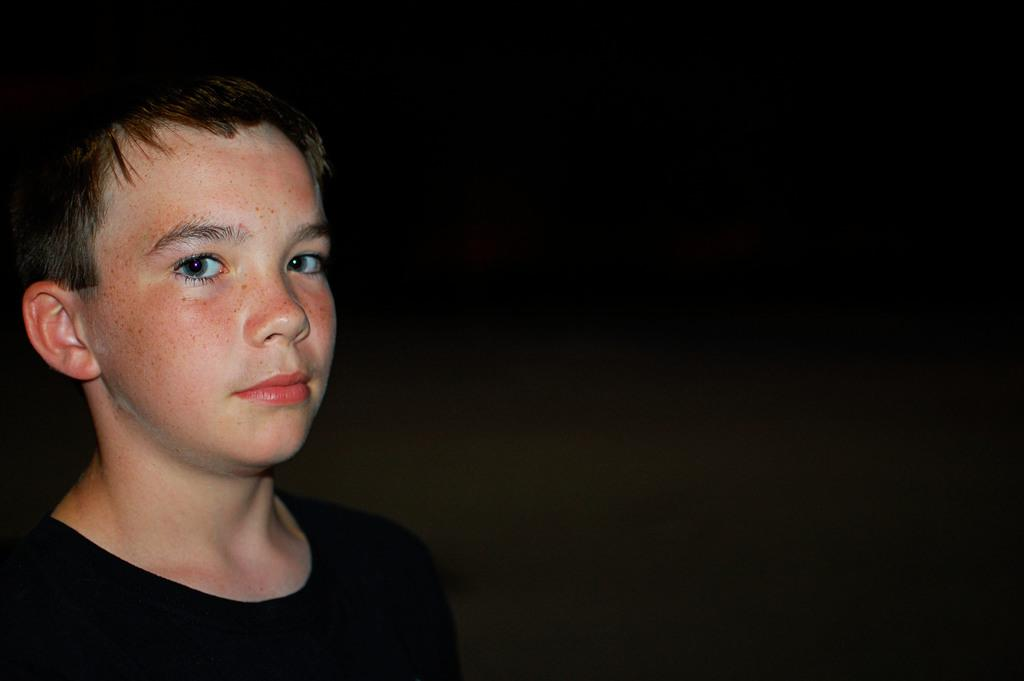What is the main subject in the foreground of the image? There is a boy in the foreground of the image. What is the boy wearing? The boy is wearing a black T-shirt. On which side of the image is the boy located? The boy is on the left side of the image. What can be observed about the background of the image? The background of the image is dark. How many ladybugs can be seen on the plate in the image? There is no plate or ladybugs present in the image. 